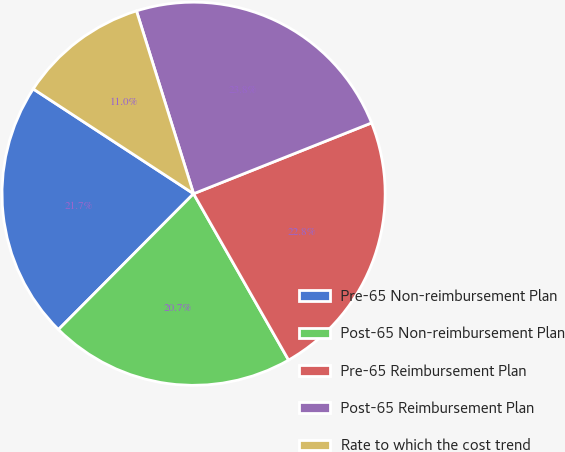<chart> <loc_0><loc_0><loc_500><loc_500><pie_chart><fcel>Pre-65 Non-reimbursement Plan<fcel>Post-65 Non-reimbursement Plan<fcel>Pre-65 Reimbursement Plan<fcel>Post-65 Reimbursement Plan<fcel>Rate to which the cost trend<nl><fcel>21.75%<fcel>20.72%<fcel>22.77%<fcel>23.79%<fcel>10.97%<nl></chart> 